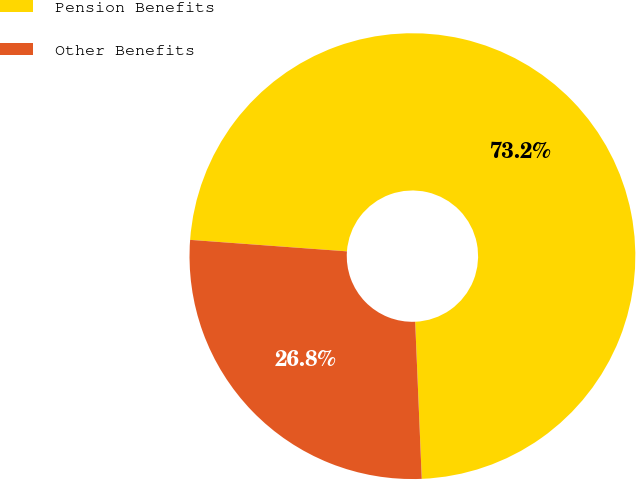Convert chart. <chart><loc_0><loc_0><loc_500><loc_500><pie_chart><fcel>Pension Benefits<fcel>Other Benefits<nl><fcel>73.17%<fcel>26.83%<nl></chart> 